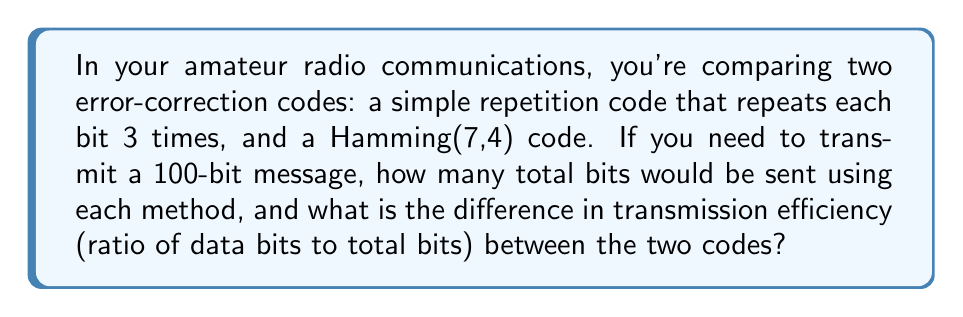Help me with this question. Let's approach this step-by-step:

1. Simple repetition code:
   - Each bit is repeated 3 times
   - For a 100-bit message: $100 \times 3 = 300$ bits sent
   - Efficiency: $\frac{\text{data bits}}{\text{total bits}} = \frac{100}{300} = \frac{1}{3}$

2. Hamming(7,4) code:
   - For every 4 data bits, 3 parity bits are added, resulting in 7 bits total
   - Number of 4-bit groups in 100-bit message: $\lceil \frac{100}{4} \rceil = 25$
   - Total bits sent: $25 \times 7 = 175$ bits
   - Efficiency: $\frac{\text{data bits}}{\text{total bits}} = \frac{100}{175} = \frac{4}{7}$

3. Difference in efficiency:
   $\frac{4}{7} - \frac{1}{3} = \frac{12}{21} - \frac{7}{21} = \frac{5}{21}$

The Hamming code is more efficient by $\frac{5}{21}$ or approximately 23.8%.
Answer: Repetition code: 300 bits, Hamming(7,4): 175 bits, Efficiency difference: $\frac{5}{21}$ 